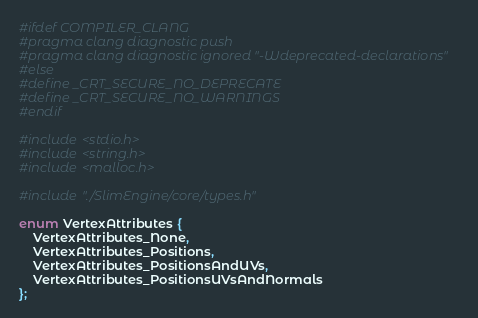Convert code to text. <code><loc_0><loc_0><loc_500><loc_500><_C_>#ifdef COMPILER_CLANG
#pragma clang diagnostic push
#pragma clang diagnostic ignored "-Wdeprecated-declarations"
#else
#define _CRT_SECURE_NO_DEPRECATE
#define _CRT_SECURE_NO_WARNINGS
#endif

#include <stdio.h>
#include <string.h>
#include <malloc.h>

#include "./SlimEngine/core/types.h"

enum VertexAttributes {
    VertexAttributes_None,
    VertexAttributes_Positions,
    VertexAttributes_PositionsAndUVs,
    VertexAttributes_PositionsUVsAndNormals
};
</code> 